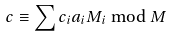<formula> <loc_0><loc_0><loc_500><loc_500>c \equiv \sum c _ { i } a _ { i } M _ { i } \bmod M</formula> 